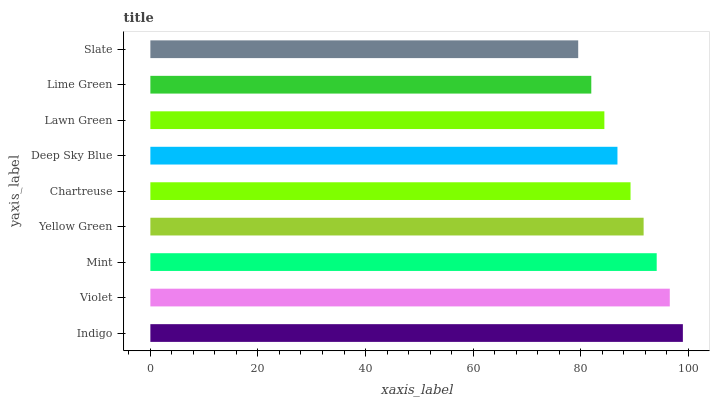Is Slate the minimum?
Answer yes or no. Yes. Is Indigo the maximum?
Answer yes or no. Yes. Is Violet the minimum?
Answer yes or no. No. Is Violet the maximum?
Answer yes or no. No. Is Indigo greater than Violet?
Answer yes or no. Yes. Is Violet less than Indigo?
Answer yes or no. Yes. Is Violet greater than Indigo?
Answer yes or no. No. Is Indigo less than Violet?
Answer yes or no. No. Is Chartreuse the high median?
Answer yes or no. Yes. Is Chartreuse the low median?
Answer yes or no. Yes. Is Slate the high median?
Answer yes or no. No. Is Yellow Green the low median?
Answer yes or no. No. 